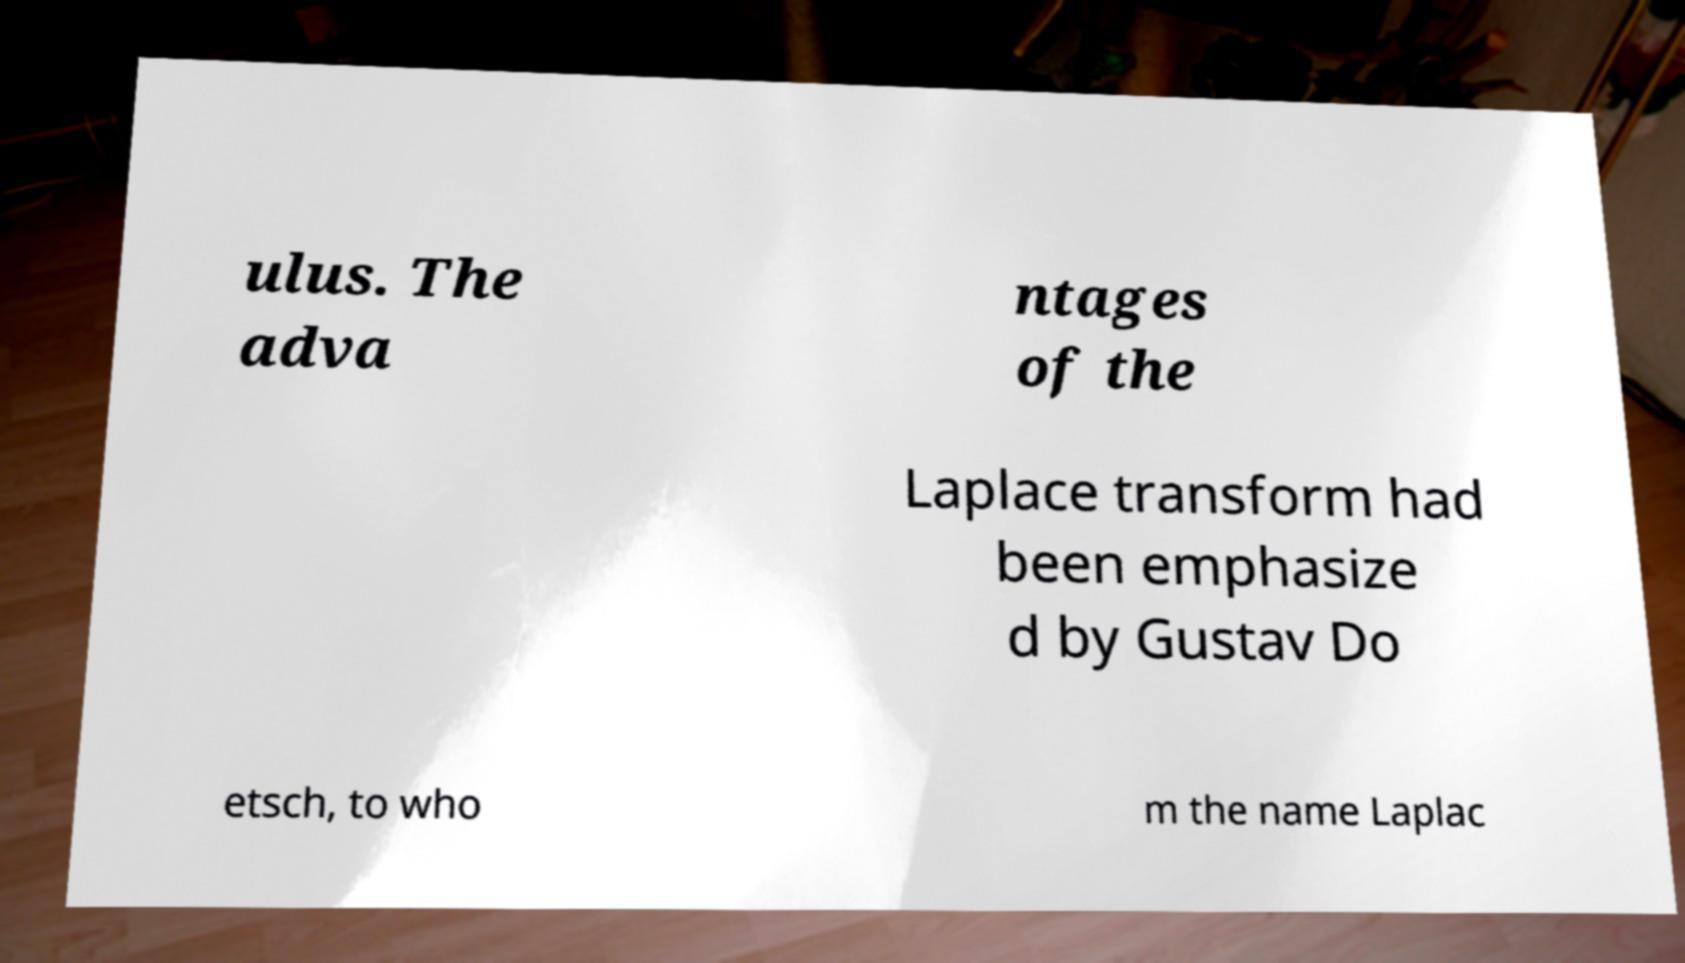Please read and relay the text visible in this image. What does it say? ulus. The adva ntages of the Laplace transform had been emphasize d by Gustav Do etsch, to who m the name Laplac 